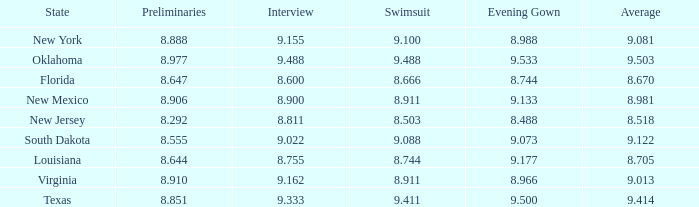 what's the evening gown where preliminaries is 8.977 9.533. 